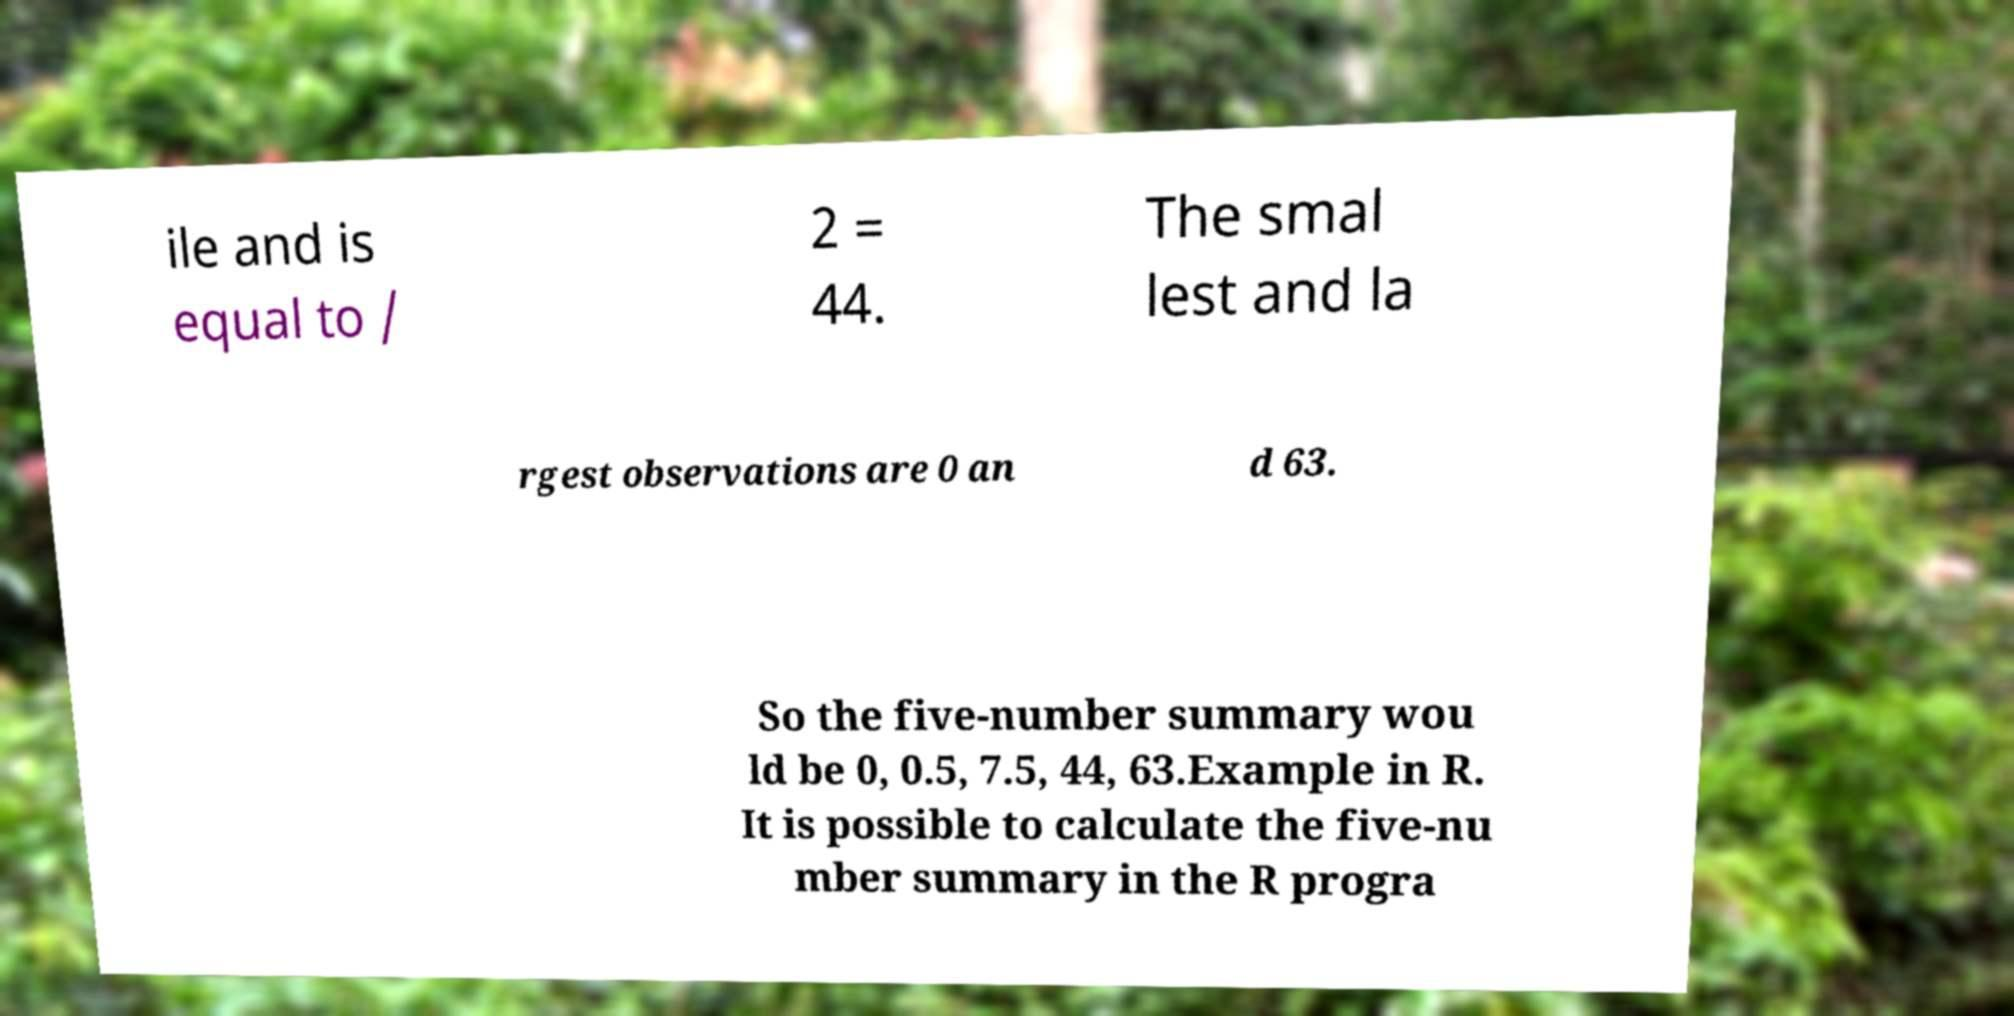Please read and relay the text visible in this image. What does it say? ile and is equal to / 2 = 44. The smal lest and la rgest observations are 0 an d 63. So the five-number summary wou ld be 0, 0.5, 7.5, 44, 63.Example in R. It is possible to calculate the five-nu mber summary in the R progra 